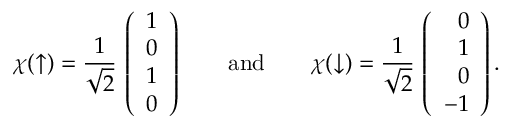<formula> <loc_0><loc_0><loc_500><loc_500>\chi ( \uparrow ) = { \frac { 1 } { \sqrt { 2 } } } \, \left ( \begin{array} { r } { 1 } \\ { 0 } \\ { 1 } \\ { 0 } \end{array} \right ) \quad a n d \quad \chi ( \downarrow ) = { \frac { 1 } { \sqrt { 2 } } } \, \left ( \begin{array} { r } { 0 } \\ { 1 } \\ { 0 } \\ { - 1 } \end{array} \right ) .</formula> 